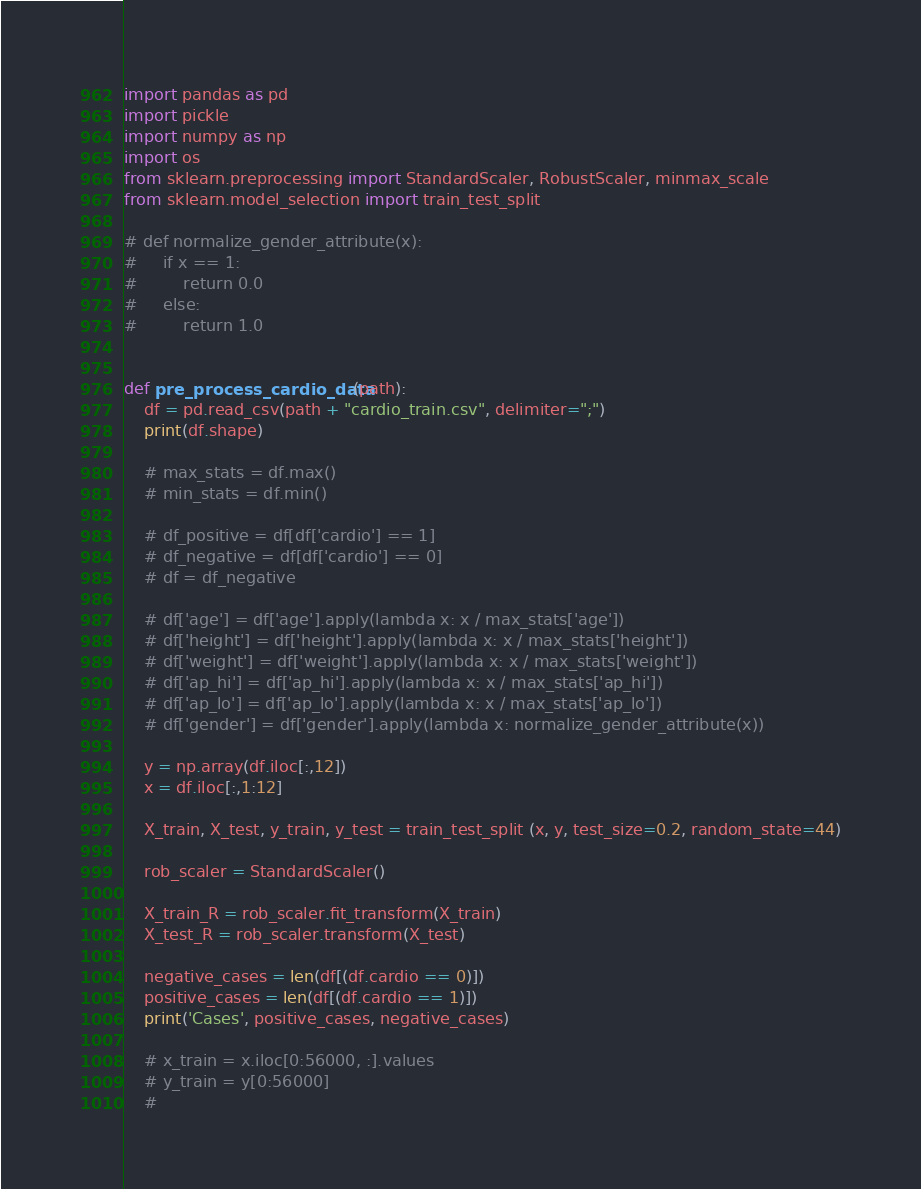Convert code to text. <code><loc_0><loc_0><loc_500><loc_500><_Python_>import pandas as pd
import pickle
import numpy as np
import os
from sklearn.preprocessing import StandardScaler, RobustScaler, minmax_scale
from sklearn.model_selection import train_test_split

# def normalize_gender_attribute(x):
#     if x == 1:
#         return 0.0
#     else:
#         return 1.0


def pre_process_cardio_data(path):
    df = pd.read_csv(path + "cardio_train.csv", delimiter=";")
    print(df.shape)

    # max_stats = df.max()
    # min_stats = df.min()

    # df_positive = df[df['cardio'] == 1]
    # df_negative = df[df['cardio'] == 0]
    # df = df_negative

    # df['age'] = df['age'].apply(lambda x: x / max_stats['age'])
    # df['height'] = df['height'].apply(lambda x: x / max_stats['height'])
    # df['weight'] = df['weight'].apply(lambda x: x / max_stats['weight'])
    # df['ap_hi'] = df['ap_hi'].apply(lambda x: x / max_stats['ap_hi'])
    # df['ap_lo'] = df['ap_lo'].apply(lambda x: x / max_stats['ap_lo'])
    # df['gender'] = df['gender'].apply(lambda x: normalize_gender_attribute(x))

    y = np.array(df.iloc[:,12])
    x = df.iloc[:,1:12]

    X_train, X_test, y_train, y_test = train_test_split (x, y, test_size=0.2, random_state=44)

    rob_scaler = StandardScaler()

    X_train_R = rob_scaler.fit_transform(X_train)
    X_test_R = rob_scaler.transform(X_test)

    negative_cases = len(df[(df.cardio == 0)])
    positive_cases = len(df[(df.cardio == 1)])
    print('Cases', positive_cases, negative_cases)

    # x_train = x.iloc[0:56000, :].values
    # y_train = y[0:56000]
    #</code> 